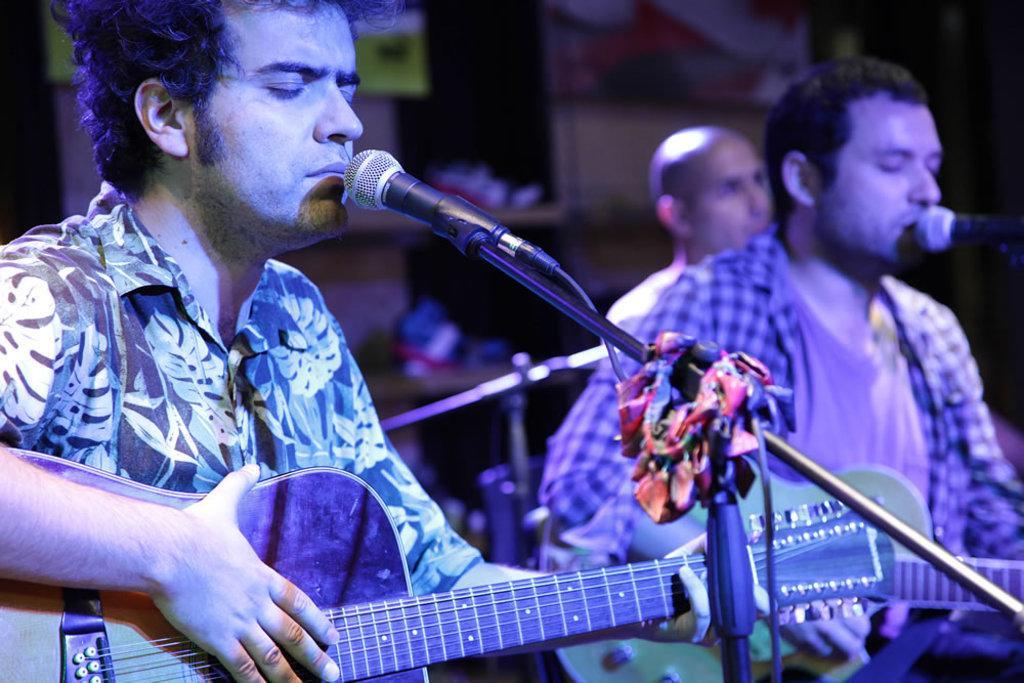Can you describe this image briefly? In this image there are persons sitting and holding a musical instrument in their hands and the man on the right side is singing in front of the mic and the man in the center is holding a musical instrument and there is a mic in front of the man 